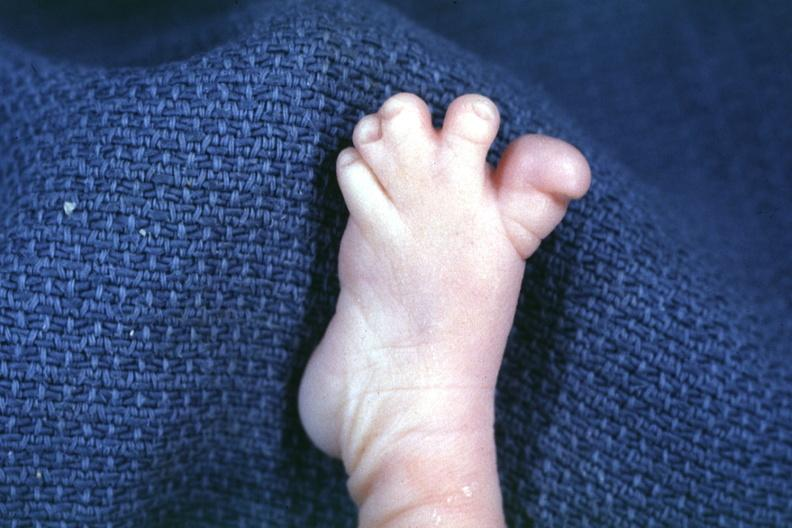what is present?
Answer the question using a single word or phrase. Foot 